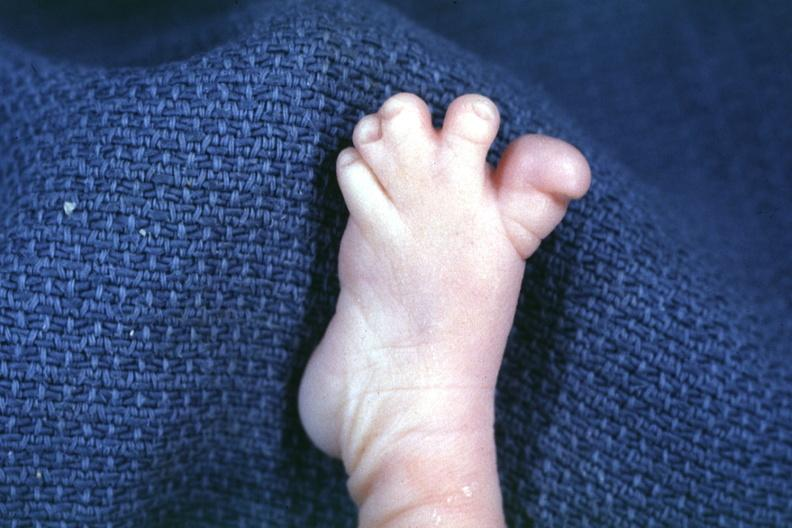what is present?
Answer the question using a single word or phrase. Foot 